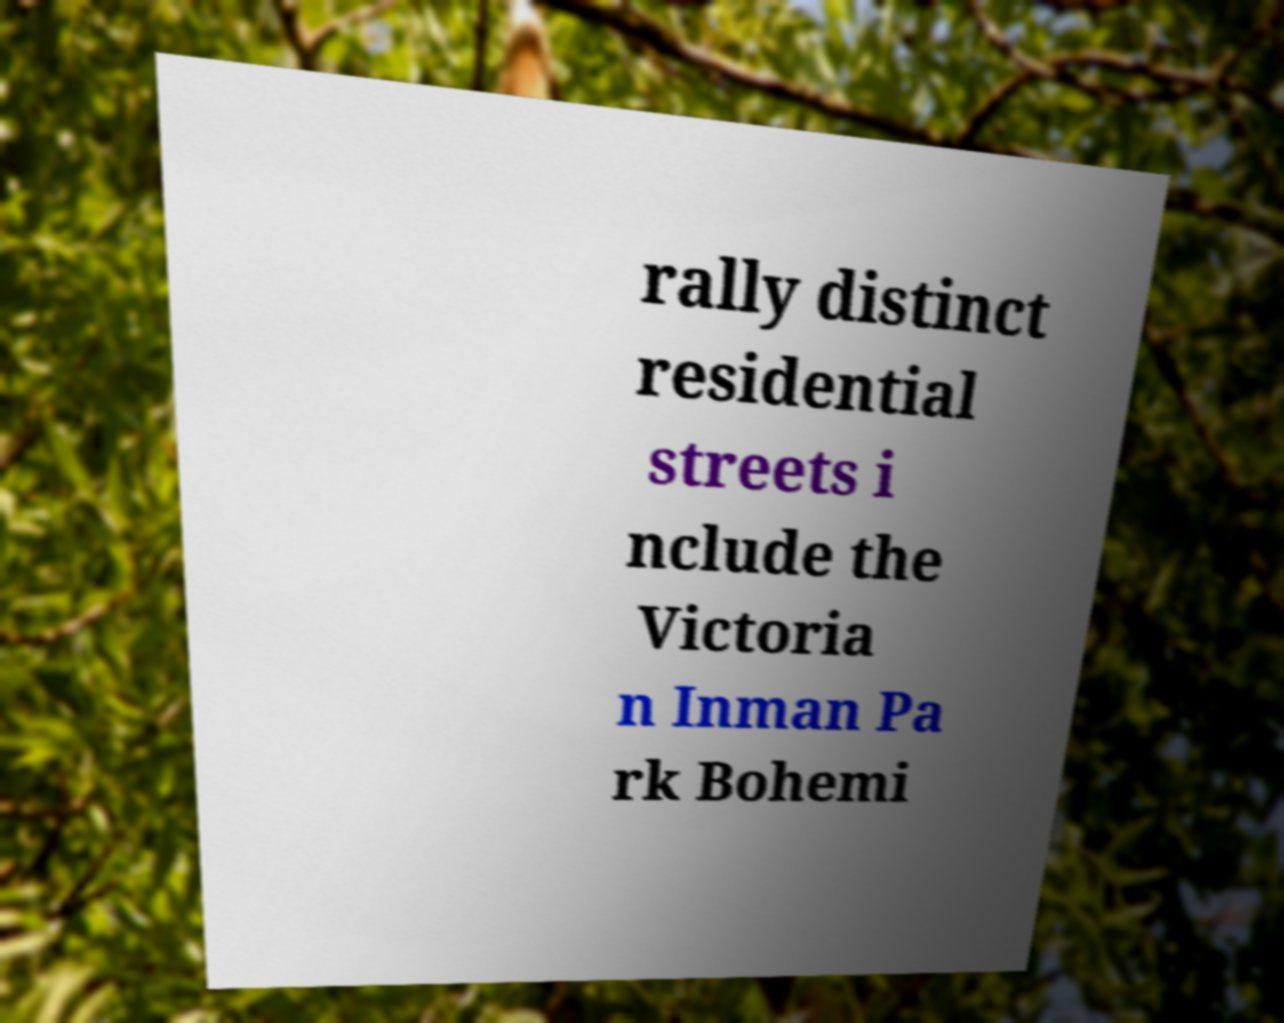Can you accurately transcribe the text from the provided image for me? rally distinct residential streets i nclude the Victoria n Inman Pa rk Bohemi 